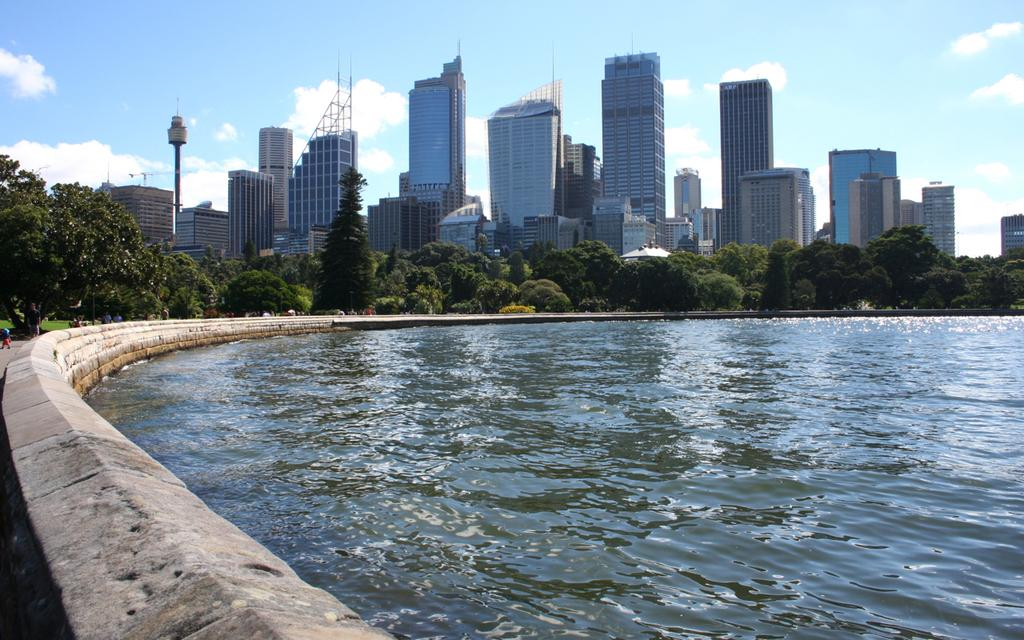What is the primary element in the image? There is water in the image. What type of vegetation is present in the image? There are trees in the image, described as green. What type of structures are visible in the image? There are buildings in the image, described as white. What other objects can be seen in the image? There are poles in the image. What is visible in the sky in the image? The sky is visible in the image, described as blue and white. Can you see any dinosaurs in the image? No, there are no dinosaurs present in the image. What type of cap is the tree wearing in the image? Trees do not wear caps, so this question is not applicable to the image. 